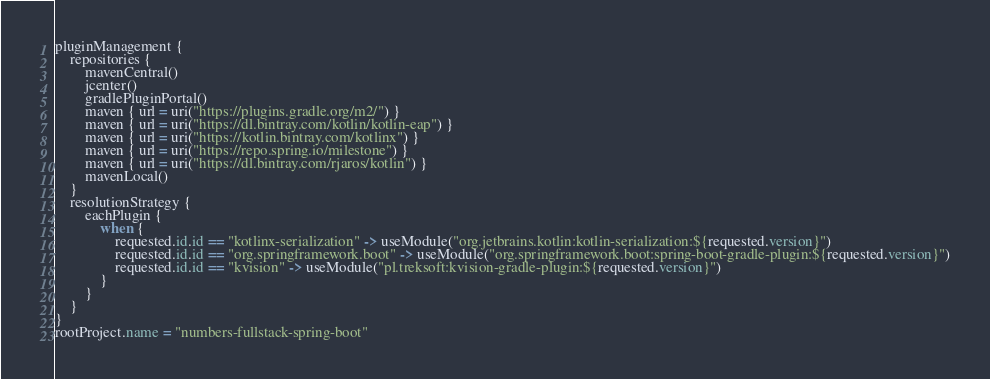<code> <loc_0><loc_0><loc_500><loc_500><_Kotlin_>pluginManagement {
    repositories {
        mavenCentral()
        jcenter()
        gradlePluginPortal()
        maven { url = uri("https://plugins.gradle.org/m2/") }
        maven { url = uri("https://dl.bintray.com/kotlin/kotlin-eap") }
        maven { url = uri("https://kotlin.bintray.com/kotlinx") }
        maven { url = uri("https://repo.spring.io/milestone") }
        maven { url = uri("https://dl.bintray.com/rjaros/kotlin") }
        mavenLocal()
    }
    resolutionStrategy {
        eachPlugin {
            when {
                requested.id.id == "kotlinx-serialization" -> useModule("org.jetbrains.kotlin:kotlin-serialization:${requested.version}")
                requested.id.id == "org.springframework.boot" -> useModule("org.springframework.boot:spring-boot-gradle-plugin:${requested.version}")
                requested.id.id == "kvision" -> useModule("pl.treksoft:kvision-gradle-plugin:${requested.version}")
            }
        }
    }
}
rootProject.name = "numbers-fullstack-spring-boot"
</code> 